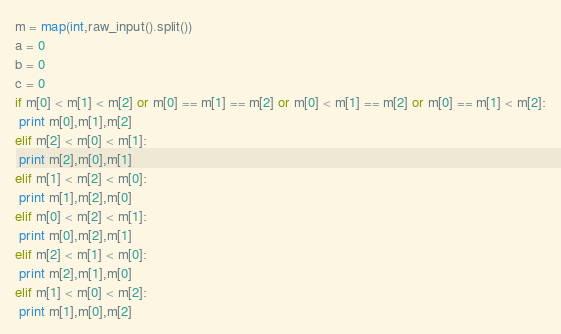Convert code to text. <code><loc_0><loc_0><loc_500><loc_500><_Python_>m = map(int,raw_input().split())
a = 0
b = 0
c = 0
if m[0] < m[1] < m[2] or m[0] == m[1] == m[2] or m[0] < m[1] == m[2] or m[0] == m[1] < m[2]:
 print m[0],m[1],m[2]
elif m[2] < m[0] < m[1]:
 print m[2],m[0],m[1]
elif m[1] < m[2] < m[0]:
 print m[1],m[2],m[0]
elif m[0] < m[2] < m[1]:
 print m[0],m[2],m[1]
elif m[2] < m[1] < m[0]:
 print m[2],m[1],m[0]
elif m[1] < m[0] < m[2]:
 print m[1],m[0],m[2]</code> 